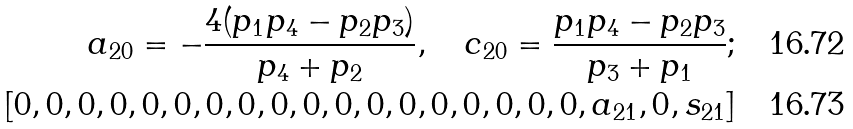Convert formula to latex. <formula><loc_0><loc_0><loc_500><loc_500>a _ { 2 0 } = - \frac { 4 ( p _ { 1 } p _ { 4 } - p _ { 2 } p _ { 3 } ) } { p _ { 4 } + p _ { 2 } } , \quad c _ { 2 0 } = \frac { p _ { 1 } p _ { 4 } - p _ { 2 } p _ { 3 } } { p _ { 3 } + p _ { 1 } } ; \\ [ 0 , 0 , 0 , 0 , 0 , 0 , 0 , 0 , 0 , 0 , 0 , 0 , 0 , 0 , 0 , 0 , 0 , 0 , a _ { 2 1 } , 0 , s _ { 2 1 } ]</formula> 